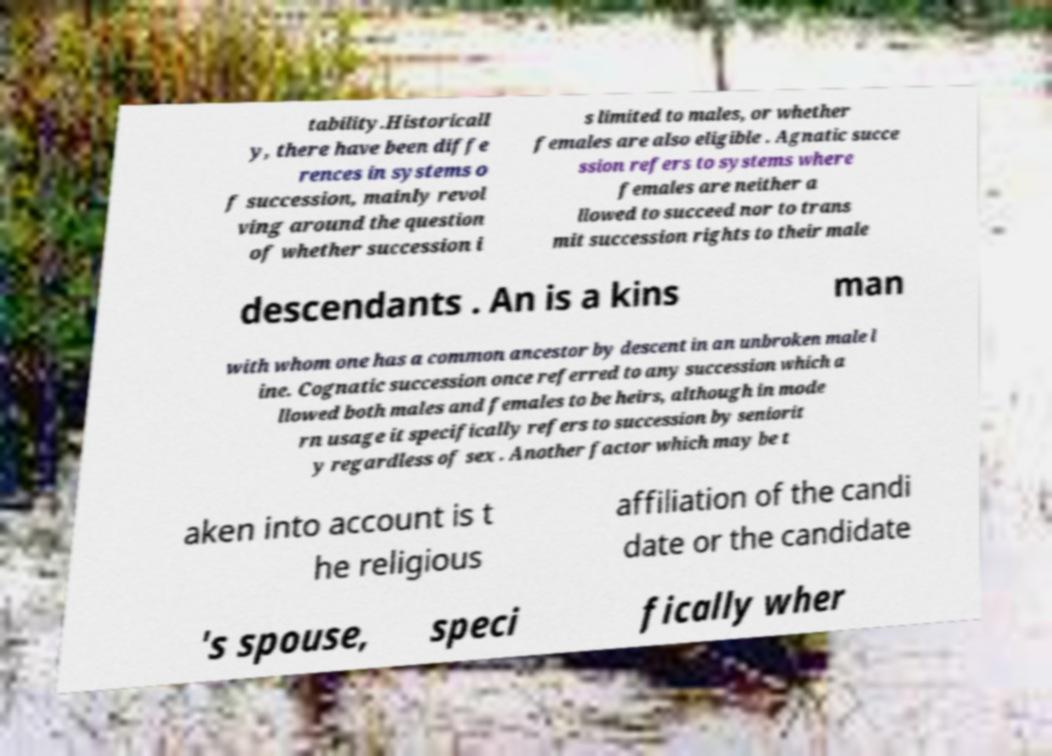Could you extract and type out the text from this image? tability.Historicall y, there have been diffe rences in systems o f succession, mainly revol ving around the question of whether succession i s limited to males, or whether females are also eligible . Agnatic succe ssion refers to systems where females are neither a llowed to succeed nor to trans mit succession rights to their male descendants . An is a kins man with whom one has a common ancestor by descent in an unbroken male l ine. Cognatic succession once referred to any succession which a llowed both males and females to be heirs, although in mode rn usage it specifically refers to succession by seniorit y regardless of sex . Another factor which may be t aken into account is t he religious affiliation of the candi date or the candidate 's spouse, speci fically wher 